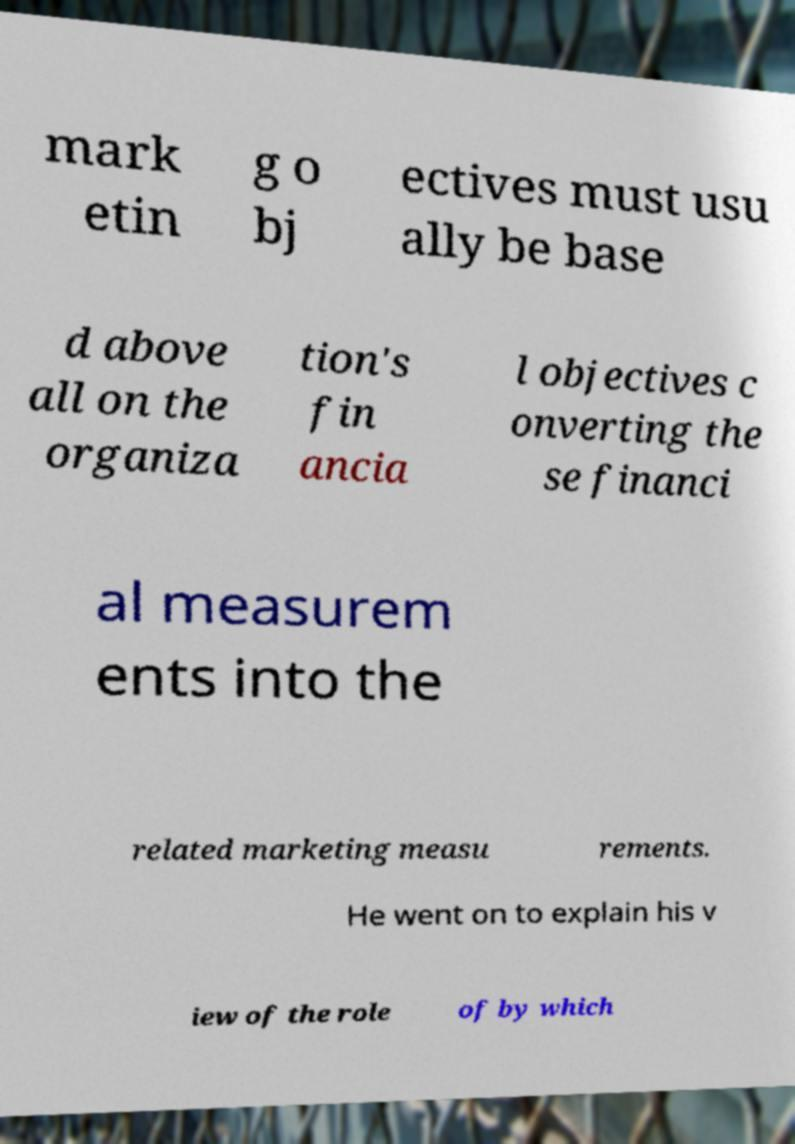What messages or text are displayed in this image? I need them in a readable, typed format. mark etin g o bj ectives must usu ally be base d above all on the organiza tion's fin ancia l objectives c onverting the se financi al measurem ents into the related marketing measu rements. He went on to explain his v iew of the role of by which 